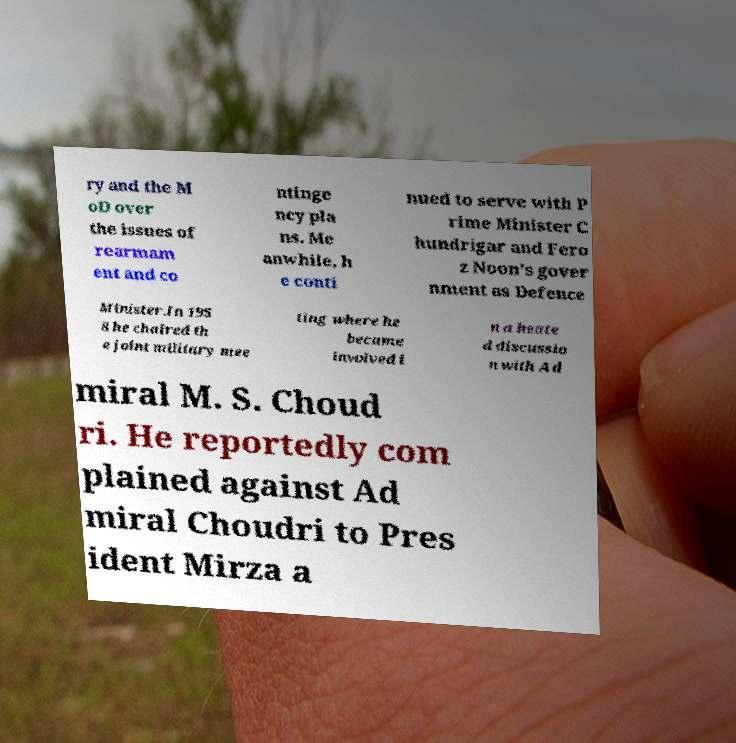Please read and relay the text visible in this image. What does it say? ry and the M oD over the issues of rearmam ent and co ntinge ncy pla ns. Me anwhile, h e conti nued to serve with P rime Minister C hundrigar and Fero z Noon's gover nment as Defence Minister.In 195 8 he chaired th e joint military mee ting where he became involved i n a heate d discussio n with Ad miral M. S. Choud ri. He reportedly com plained against Ad miral Choudri to Pres ident Mirza a 